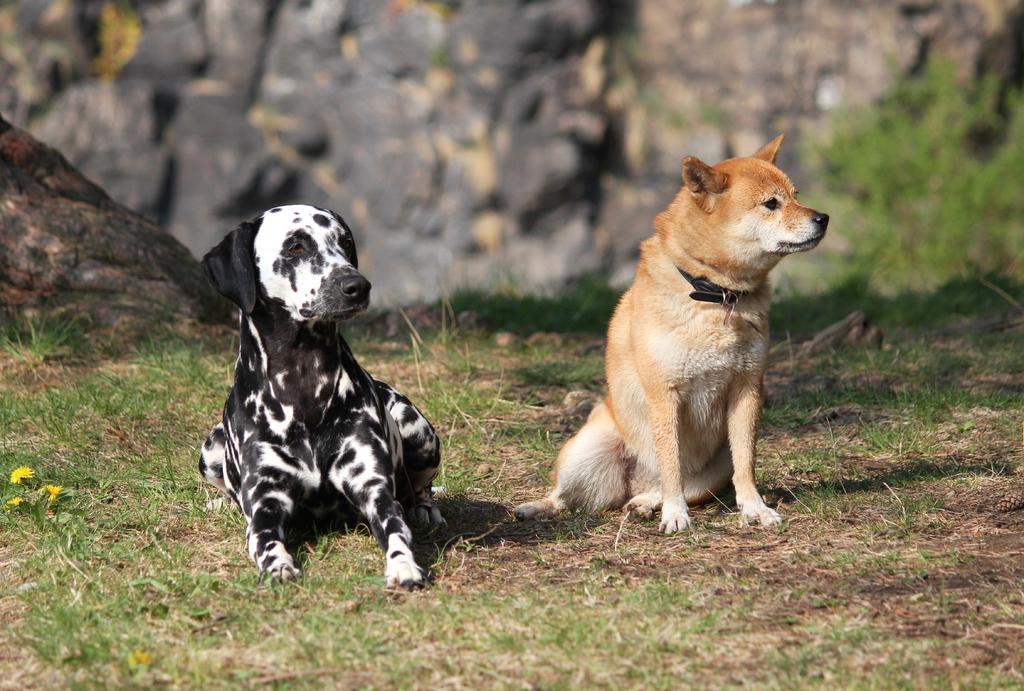Please provide a concise description of this image. This image consists of two dogs in black and brown color. At the bottom, there is green grass on the ground. In the background, there are rocks. 